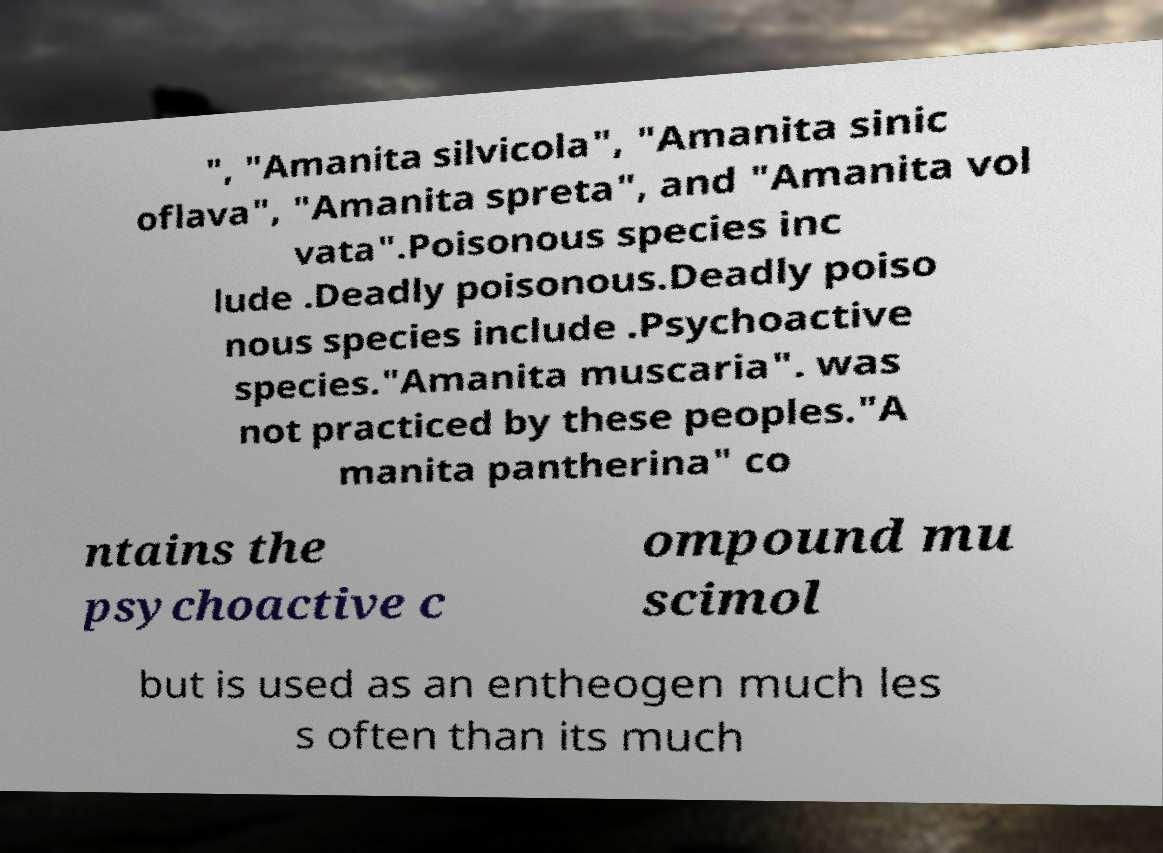Can you accurately transcribe the text from the provided image for me? ", "Amanita silvicola", "Amanita sinic oflava", "Amanita spreta", and "Amanita vol vata".Poisonous species inc lude .Deadly poisonous.Deadly poiso nous species include .Psychoactive species."Amanita muscaria". was not practiced by these peoples."A manita pantherina" co ntains the psychoactive c ompound mu scimol but is used as an entheogen much les s often than its much 